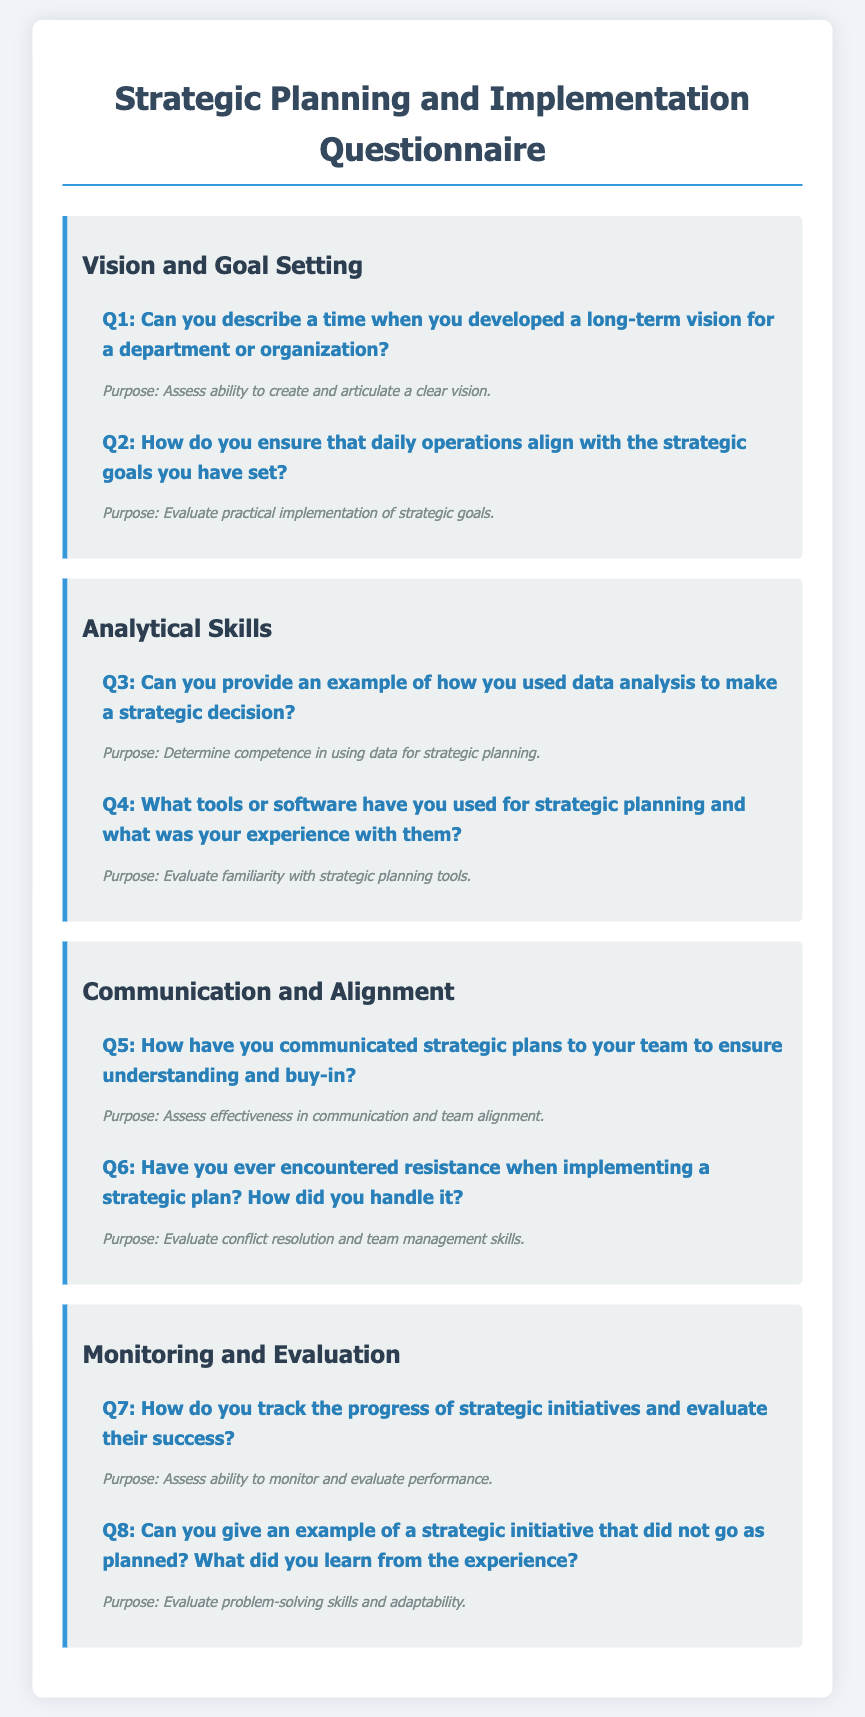What is the title of the document? The title of the document is prominently displayed at the top of the rendered page.
Answer: Strategic Planning and Implementation Questionnaire How many categories are in the document? The document consists of several distinct categories, each focusing on a specific area of strategic planning.
Answer: 4 What is the purpose of question 1? Each question in the document includes an explanation of its purpose, found directly below the question text.
Answer: Assess ability to create and articulate a clear vision What is the main color theme of the document? The color scheme can be observed in various elements of the document, such as headers, category backgrounds, and text colors.
Answer: Blue and gray Which question number addresses resistance in strategic planning? The numbering of the questions indicates their sequential order, helping to locate specific topics quickly.
Answer: Q6 What category does question 5 belong to? The questions are grouped into categories, indicating their relevance to specific aspects of strategic planning and implementation.
Answer: Communication and Alignment What is the designed response format for answers? The document outlines how responses should be evaluated or understood based on the questions provided.
Answer: Short-answer questions How are progress and success tracked according to the document? A specific question addresses methods for tracking strategic initiatives, suggesting a focus on monitoring and evaluation practices.
Answer: Q7 